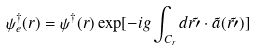Convert formula to latex. <formula><loc_0><loc_0><loc_500><loc_500>\psi _ { e } ^ { \dag } ( r ) = \psi ^ { \dag } ( r ) \exp [ - i g \int _ { C _ { r } } d \vec { r \prime } \cdot \vec { a } ( \vec { r \prime } ) ]</formula> 